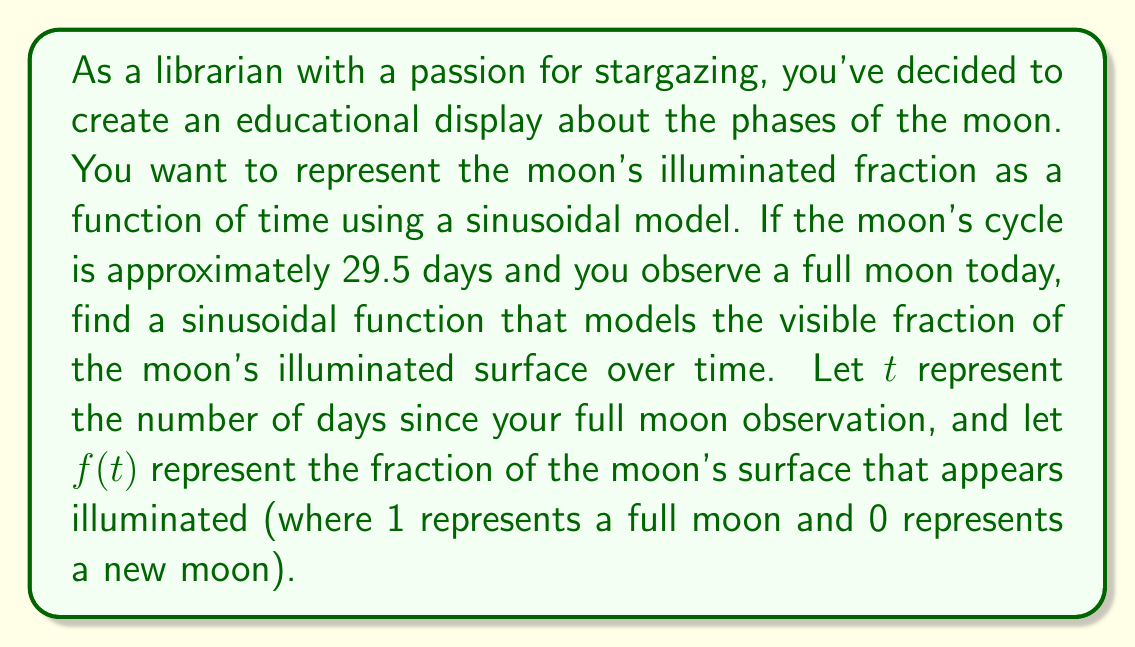Help me with this question. To model the moon's phases using a sinusoidal function, we'll follow these steps:

1) The general form of a sinusoidal function is:
   $$ f(t) = A \sin(B(t - C)) + D $$
   where $A$ is the amplitude, $B$ is the frequency, $C$ is the phase shift, and $D$ is the vertical shift.

2) We know that the moon's cycle is 29.5 days, so the period of our function should be 29.5. The frequency $B$ is related to the period by $B = \frac{2\pi}{period}$. Thus:
   $$ B = \frac{2\pi}{29.5} $$

3) The fraction of the moon's surface illuminated varies from 0 (new moon) to 1 (full moon). This means our function should oscillate between 0 and 1. To achieve this:
   - The amplitude $A$ should be 0.5
   - The vertical shift $D$ should also be 0.5
   This way, the function will oscillate between $0.5 - 0.5 = 0$ and $0.5 + 0.5 = 1$

4) We start at a full moon, which corresponds to the maximum of our function. To ensure we start at a maximum, we need to use a cosine function instead of a sine function. We can convert our sine function to a cosine function by subtracting $\frac{\pi}{2}$ from the argument:
   $$ f(t) = 0.5 \cos(B(t - C)) + 0.5 $$

5) Since we start at a full moon when $t = 0$, we don't need a phase shift, so $C = 0$.

6) Putting it all together, our function is:
   $$ f(t) = 0.5 \cos(\frac{2\pi}{29.5}t) + 0.5 $$

This function will give the illuminated fraction of the moon's surface $t$ days after the observed full moon.
Answer: $$ f(t) = 0.5 \cos(\frac{2\pi}{29.5}t) + 0.5 $$
where $t$ is the number of days since the full moon observation and $f(t)$ is the fraction of the moon's surface that appears illuminated. 